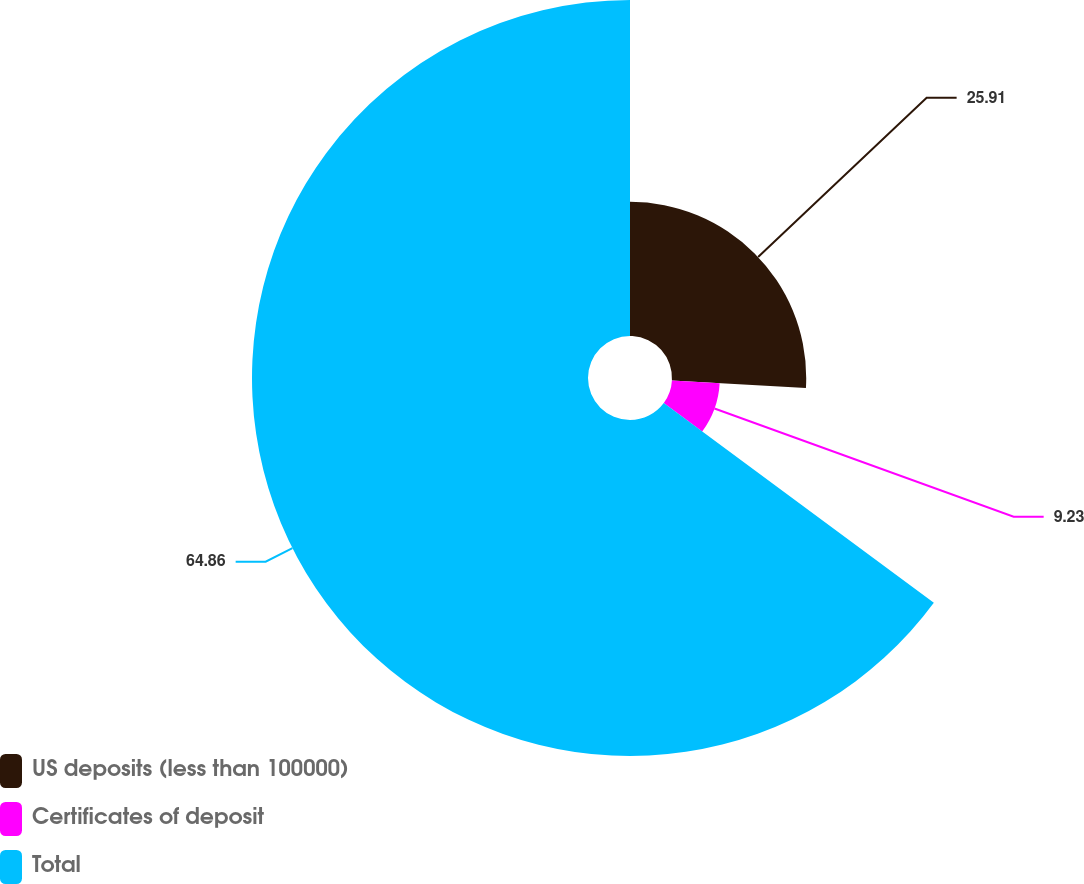Convert chart. <chart><loc_0><loc_0><loc_500><loc_500><pie_chart><fcel>US deposits (less than 100000)<fcel>Certificates of deposit<fcel>Total<nl><fcel>25.91%<fcel>9.23%<fcel>64.86%<nl></chart> 